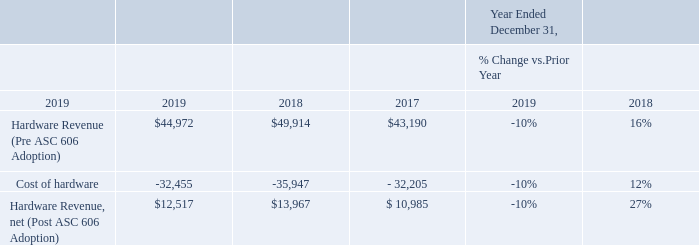Hardware
Hardware sales, net decreased $1.5 million, or -10% in 2019 compared to 2018. We adopted the new ASC 606 standard as of January 1, 2018 and elected to use the modified retrospective method. Historical hardware sales prior to the adoption of ASC 606 were recorded on a gross basis, as we were the principal in the transaction in accordance with the previous standard, ASC 605-45. Under the new standard, we are an agent in the transaction as we do not physically control the hardware which we sell. Accordingly, starting January 1, 2018, we recognize our hardware revenue net of related cost which reduces both hardware revenue and cost of sales as compared to our accounting prior to 2018. For comparison purposes only, had we implemented ASC 606 using the full retrospective method, we would have also presented hardware revenue net of cost for prior periods as shown below.
The majority of hardware sales are derived from our Americas segment. Sales of hardware are largely dependent upon customer- specific desires, which fluctuate.
What is the revenue from hardware, net (Post ASC 606 Adoption) in 2019 $12,517. What is the percentage change in cost of hardware between 2019 and 2018? -10%. When is ASC 606 being adopted by the company? January 1, 2018. What is the change in hardware revenue, net (Post ASC 606 Adoption) between 2019 and 2017? $12,517-$10,985
Answer: 1532. What is the change in hardware revenue (Pre ASC 606 Adoption) in 2019 and 2018? $44,972-$49,914
Answer: -4942. What is the sum of cost of hardware for 2019 and 2018? $32,455+$35,947
Answer: 68402. 